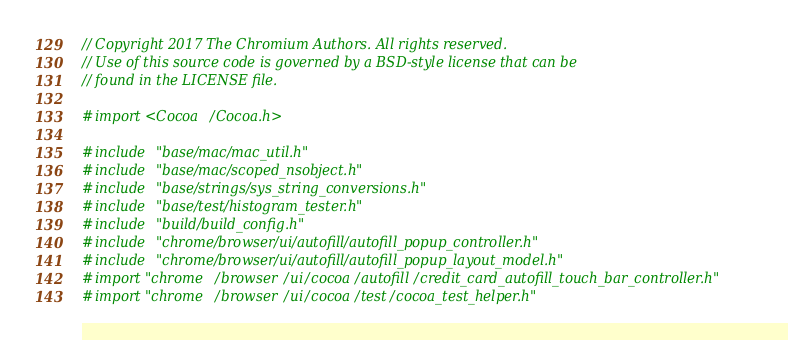Convert code to text. <code><loc_0><loc_0><loc_500><loc_500><_ObjectiveC_>// Copyright 2017 The Chromium Authors. All rights reserved.
// Use of this source code is governed by a BSD-style license that can be
// found in the LICENSE file.

#import <Cocoa/Cocoa.h>

#include "base/mac/mac_util.h"
#include "base/mac/scoped_nsobject.h"
#include "base/strings/sys_string_conversions.h"
#include "base/test/histogram_tester.h"
#include "build/build_config.h"
#include "chrome/browser/ui/autofill/autofill_popup_controller.h"
#include "chrome/browser/ui/autofill/autofill_popup_layout_model.h"
#import "chrome/browser/ui/cocoa/autofill/credit_card_autofill_touch_bar_controller.h"
#import "chrome/browser/ui/cocoa/test/cocoa_test_helper.h"</code> 